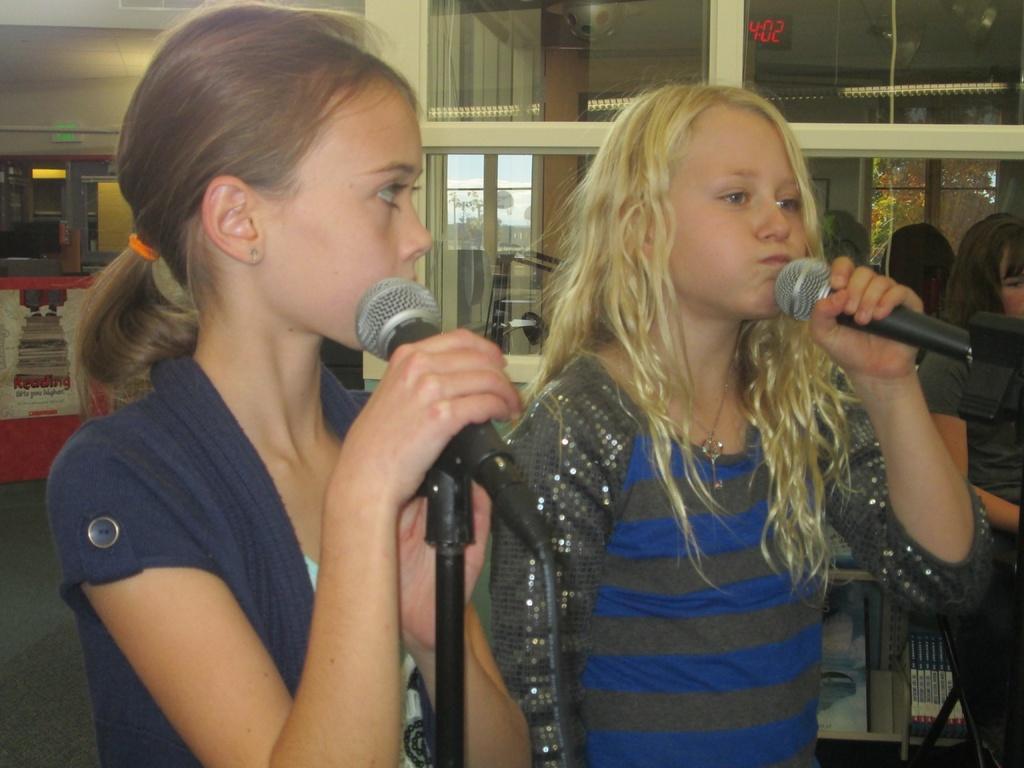How would you summarize this image in a sentence or two? In this picture we can see two girls. They are holding a microphone in their hands and they are talking. We can observe a woman on the right side. 